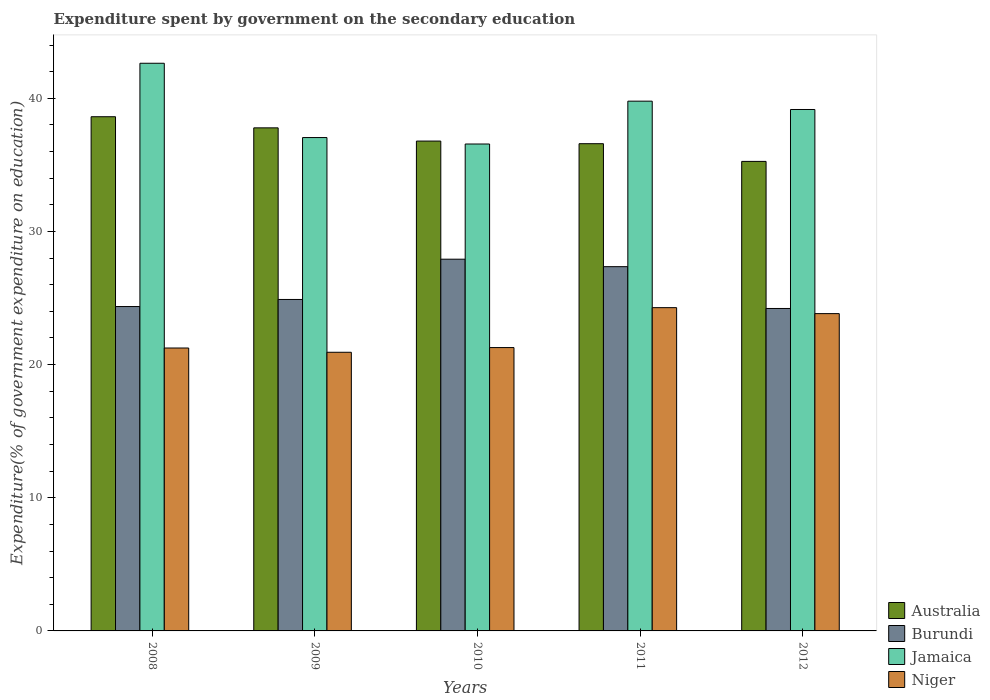How many groups of bars are there?
Offer a terse response. 5. What is the label of the 1st group of bars from the left?
Provide a succinct answer. 2008. What is the expenditure spent by government on the secondary education in Burundi in 2009?
Keep it short and to the point. 24.89. Across all years, what is the maximum expenditure spent by government on the secondary education in Burundi?
Give a very brief answer. 27.92. Across all years, what is the minimum expenditure spent by government on the secondary education in Niger?
Your answer should be compact. 20.93. In which year was the expenditure spent by government on the secondary education in Niger minimum?
Your response must be concise. 2009. What is the total expenditure spent by government on the secondary education in Niger in the graph?
Keep it short and to the point. 111.56. What is the difference between the expenditure spent by government on the secondary education in Australia in 2010 and that in 2011?
Your answer should be very brief. 0.2. What is the difference between the expenditure spent by government on the secondary education in Niger in 2011 and the expenditure spent by government on the secondary education in Jamaica in 2010?
Offer a terse response. -12.29. What is the average expenditure spent by government on the secondary education in Niger per year?
Your answer should be very brief. 22.31. In the year 2011, what is the difference between the expenditure spent by government on the secondary education in Niger and expenditure spent by government on the secondary education in Burundi?
Your answer should be very brief. -3.08. What is the ratio of the expenditure spent by government on the secondary education in Australia in 2008 to that in 2009?
Offer a very short reply. 1.02. What is the difference between the highest and the second highest expenditure spent by government on the secondary education in Niger?
Give a very brief answer. 0.45. What is the difference between the highest and the lowest expenditure spent by government on the secondary education in Jamaica?
Keep it short and to the point. 6.06. Is it the case that in every year, the sum of the expenditure spent by government on the secondary education in Niger and expenditure spent by government on the secondary education in Burundi is greater than the sum of expenditure spent by government on the secondary education in Jamaica and expenditure spent by government on the secondary education in Australia?
Keep it short and to the point. No. What does the 4th bar from the left in 2011 represents?
Your response must be concise. Niger. What does the 2nd bar from the right in 2011 represents?
Provide a succinct answer. Jamaica. How many bars are there?
Offer a terse response. 20. Are all the bars in the graph horizontal?
Offer a very short reply. No. Does the graph contain any zero values?
Give a very brief answer. No. How many legend labels are there?
Provide a succinct answer. 4. What is the title of the graph?
Offer a terse response. Expenditure spent by government on the secondary education. What is the label or title of the X-axis?
Your answer should be compact. Years. What is the label or title of the Y-axis?
Your answer should be compact. Expenditure(% of government expenditure on education). What is the Expenditure(% of government expenditure on education) in Australia in 2008?
Your answer should be compact. 38.62. What is the Expenditure(% of government expenditure on education) of Burundi in 2008?
Your answer should be very brief. 24.36. What is the Expenditure(% of government expenditure on education) of Jamaica in 2008?
Your answer should be compact. 42.63. What is the Expenditure(% of government expenditure on education) in Niger in 2008?
Offer a very short reply. 21.25. What is the Expenditure(% of government expenditure on education) in Australia in 2009?
Keep it short and to the point. 37.78. What is the Expenditure(% of government expenditure on education) of Burundi in 2009?
Offer a very short reply. 24.89. What is the Expenditure(% of government expenditure on education) of Jamaica in 2009?
Keep it short and to the point. 37.05. What is the Expenditure(% of government expenditure on education) in Niger in 2009?
Your answer should be compact. 20.93. What is the Expenditure(% of government expenditure on education) of Australia in 2010?
Offer a terse response. 36.79. What is the Expenditure(% of government expenditure on education) of Burundi in 2010?
Give a very brief answer. 27.92. What is the Expenditure(% of government expenditure on education) in Jamaica in 2010?
Offer a very short reply. 36.57. What is the Expenditure(% of government expenditure on education) in Niger in 2010?
Ensure brevity in your answer.  21.28. What is the Expenditure(% of government expenditure on education) of Australia in 2011?
Provide a short and direct response. 36.59. What is the Expenditure(% of government expenditure on education) in Burundi in 2011?
Provide a short and direct response. 27.36. What is the Expenditure(% of government expenditure on education) of Jamaica in 2011?
Provide a succinct answer. 39.79. What is the Expenditure(% of government expenditure on education) of Niger in 2011?
Provide a short and direct response. 24.28. What is the Expenditure(% of government expenditure on education) of Australia in 2012?
Your answer should be very brief. 35.26. What is the Expenditure(% of government expenditure on education) in Burundi in 2012?
Your answer should be very brief. 24.22. What is the Expenditure(% of government expenditure on education) of Jamaica in 2012?
Offer a terse response. 39.16. What is the Expenditure(% of government expenditure on education) of Niger in 2012?
Give a very brief answer. 23.83. Across all years, what is the maximum Expenditure(% of government expenditure on education) in Australia?
Offer a very short reply. 38.62. Across all years, what is the maximum Expenditure(% of government expenditure on education) of Burundi?
Your answer should be compact. 27.92. Across all years, what is the maximum Expenditure(% of government expenditure on education) in Jamaica?
Make the answer very short. 42.63. Across all years, what is the maximum Expenditure(% of government expenditure on education) in Niger?
Keep it short and to the point. 24.28. Across all years, what is the minimum Expenditure(% of government expenditure on education) in Australia?
Give a very brief answer. 35.26. Across all years, what is the minimum Expenditure(% of government expenditure on education) in Burundi?
Offer a very short reply. 24.22. Across all years, what is the minimum Expenditure(% of government expenditure on education) of Jamaica?
Your answer should be compact. 36.57. Across all years, what is the minimum Expenditure(% of government expenditure on education) of Niger?
Offer a terse response. 20.93. What is the total Expenditure(% of government expenditure on education) in Australia in the graph?
Provide a short and direct response. 185.04. What is the total Expenditure(% of government expenditure on education) of Burundi in the graph?
Ensure brevity in your answer.  128.74. What is the total Expenditure(% of government expenditure on education) of Jamaica in the graph?
Provide a short and direct response. 195.2. What is the total Expenditure(% of government expenditure on education) of Niger in the graph?
Provide a succinct answer. 111.56. What is the difference between the Expenditure(% of government expenditure on education) in Australia in 2008 and that in 2009?
Your response must be concise. 0.83. What is the difference between the Expenditure(% of government expenditure on education) in Burundi in 2008 and that in 2009?
Your answer should be very brief. -0.53. What is the difference between the Expenditure(% of government expenditure on education) in Jamaica in 2008 and that in 2009?
Your answer should be very brief. 5.58. What is the difference between the Expenditure(% of government expenditure on education) in Niger in 2008 and that in 2009?
Your answer should be very brief. 0.32. What is the difference between the Expenditure(% of government expenditure on education) of Australia in 2008 and that in 2010?
Your answer should be compact. 1.83. What is the difference between the Expenditure(% of government expenditure on education) in Burundi in 2008 and that in 2010?
Offer a terse response. -3.56. What is the difference between the Expenditure(% of government expenditure on education) of Jamaica in 2008 and that in 2010?
Your answer should be compact. 6.06. What is the difference between the Expenditure(% of government expenditure on education) in Niger in 2008 and that in 2010?
Ensure brevity in your answer.  -0.03. What is the difference between the Expenditure(% of government expenditure on education) of Australia in 2008 and that in 2011?
Your answer should be very brief. 2.03. What is the difference between the Expenditure(% of government expenditure on education) of Burundi in 2008 and that in 2011?
Offer a very short reply. -2.99. What is the difference between the Expenditure(% of government expenditure on education) in Jamaica in 2008 and that in 2011?
Ensure brevity in your answer.  2.85. What is the difference between the Expenditure(% of government expenditure on education) in Niger in 2008 and that in 2011?
Offer a very short reply. -3.03. What is the difference between the Expenditure(% of government expenditure on education) of Australia in 2008 and that in 2012?
Your response must be concise. 3.35. What is the difference between the Expenditure(% of government expenditure on education) of Burundi in 2008 and that in 2012?
Your answer should be compact. 0.15. What is the difference between the Expenditure(% of government expenditure on education) in Jamaica in 2008 and that in 2012?
Offer a terse response. 3.47. What is the difference between the Expenditure(% of government expenditure on education) of Niger in 2008 and that in 2012?
Give a very brief answer. -2.58. What is the difference between the Expenditure(% of government expenditure on education) in Burundi in 2009 and that in 2010?
Keep it short and to the point. -3.02. What is the difference between the Expenditure(% of government expenditure on education) of Jamaica in 2009 and that in 2010?
Your answer should be very brief. 0.48. What is the difference between the Expenditure(% of government expenditure on education) of Niger in 2009 and that in 2010?
Your answer should be very brief. -0.35. What is the difference between the Expenditure(% of government expenditure on education) of Australia in 2009 and that in 2011?
Your response must be concise. 1.19. What is the difference between the Expenditure(% of government expenditure on education) of Burundi in 2009 and that in 2011?
Provide a short and direct response. -2.46. What is the difference between the Expenditure(% of government expenditure on education) in Jamaica in 2009 and that in 2011?
Give a very brief answer. -2.73. What is the difference between the Expenditure(% of government expenditure on education) of Niger in 2009 and that in 2011?
Your answer should be compact. -3.35. What is the difference between the Expenditure(% of government expenditure on education) in Australia in 2009 and that in 2012?
Offer a terse response. 2.52. What is the difference between the Expenditure(% of government expenditure on education) in Burundi in 2009 and that in 2012?
Make the answer very short. 0.68. What is the difference between the Expenditure(% of government expenditure on education) in Jamaica in 2009 and that in 2012?
Offer a terse response. -2.11. What is the difference between the Expenditure(% of government expenditure on education) in Niger in 2009 and that in 2012?
Offer a terse response. -2.9. What is the difference between the Expenditure(% of government expenditure on education) in Australia in 2010 and that in 2011?
Offer a very short reply. 0.2. What is the difference between the Expenditure(% of government expenditure on education) in Burundi in 2010 and that in 2011?
Your response must be concise. 0.56. What is the difference between the Expenditure(% of government expenditure on education) in Jamaica in 2010 and that in 2011?
Make the answer very short. -3.22. What is the difference between the Expenditure(% of government expenditure on education) of Niger in 2010 and that in 2011?
Your answer should be very brief. -3. What is the difference between the Expenditure(% of government expenditure on education) in Australia in 2010 and that in 2012?
Your answer should be very brief. 1.53. What is the difference between the Expenditure(% of government expenditure on education) of Burundi in 2010 and that in 2012?
Offer a very short reply. 3.7. What is the difference between the Expenditure(% of government expenditure on education) in Jamaica in 2010 and that in 2012?
Offer a very short reply. -2.59. What is the difference between the Expenditure(% of government expenditure on education) in Niger in 2010 and that in 2012?
Your answer should be very brief. -2.55. What is the difference between the Expenditure(% of government expenditure on education) in Australia in 2011 and that in 2012?
Make the answer very short. 1.33. What is the difference between the Expenditure(% of government expenditure on education) of Burundi in 2011 and that in 2012?
Give a very brief answer. 3.14. What is the difference between the Expenditure(% of government expenditure on education) of Jamaica in 2011 and that in 2012?
Your answer should be very brief. 0.63. What is the difference between the Expenditure(% of government expenditure on education) of Niger in 2011 and that in 2012?
Ensure brevity in your answer.  0.45. What is the difference between the Expenditure(% of government expenditure on education) of Australia in 2008 and the Expenditure(% of government expenditure on education) of Burundi in 2009?
Offer a very short reply. 13.72. What is the difference between the Expenditure(% of government expenditure on education) of Australia in 2008 and the Expenditure(% of government expenditure on education) of Jamaica in 2009?
Offer a very short reply. 1.56. What is the difference between the Expenditure(% of government expenditure on education) of Australia in 2008 and the Expenditure(% of government expenditure on education) of Niger in 2009?
Your response must be concise. 17.69. What is the difference between the Expenditure(% of government expenditure on education) in Burundi in 2008 and the Expenditure(% of government expenditure on education) in Jamaica in 2009?
Make the answer very short. -12.69. What is the difference between the Expenditure(% of government expenditure on education) of Burundi in 2008 and the Expenditure(% of government expenditure on education) of Niger in 2009?
Provide a succinct answer. 3.44. What is the difference between the Expenditure(% of government expenditure on education) in Jamaica in 2008 and the Expenditure(% of government expenditure on education) in Niger in 2009?
Provide a succinct answer. 21.71. What is the difference between the Expenditure(% of government expenditure on education) of Australia in 2008 and the Expenditure(% of government expenditure on education) of Burundi in 2010?
Offer a very short reply. 10.7. What is the difference between the Expenditure(% of government expenditure on education) of Australia in 2008 and the Expenditure(% of government expenditure on education) of Jamaica in 2010?
Give a very brief answer. 2.05. What is the difference between the Expenditure(% of government expenditure on education) in Australia in 2008 and the Expenditure(% of government expenditure on education) in Niger in 2010?
Keep it short and to the point. 17.34. What is the difference between the Expenditure(% of government expenditure on education) of Burundi in 2008 and the Expenditure(% of government expenditure on education) of Jamaica in 2010?
Your answer should be very brief. -12.21. What is the difference between the Expenditure(% of government expenditure on education) in Burundi in 2008 and the Expenditure(% of government expenditure on education) in Niger in 2010?
Offer a very short reply. 3.08. What is the difference between the Expenditure(% of government expenditure on education) of Jamaica in 2008 and the Expenditure(% of government expenditure on education) of Niger in 2010?
Offer a terse response. 21.35. What is the difference between the Expenditure(% of government expenditure on education) of Australia in 2008 and the Expenditure(% of government expenditure on education) of Burundi in 2011?
Keep it short and to the point. 11.26. What is the difference between the Expenditure(% of government expenditure on education) in Australia in 2008 and the Expenditure(% of government expenditure on education) in Jamaica in 2011?
Offer a terse response. -1.17. What is the difference between the Expenditure(% of government expenditure on education) of Australia in 2008 and the Expenditure(% of government expenditure on education) of Niger in 2011?
Your response must be concise. 14.34. What is the difference between the Expenditure(% of government expenditure on education) in Burundi in 2008 and the Expenditure(% of government expenditure on education) in Jamaica in 2011?
Your response must be concise. -15.42. What is the difference between the Expenditure(% of government expenditure on education) in Burundi in 2008 and the Expenditure(% of government expenditure on education) in Niger in 2011?
Make the answer very short. 0.08. What is the difference between the Expenditure(% of government expenditure on education) in Jamaica in 2008 and the Expenditure(% of government expenditure on education) in Niger in 2011?
Make the answer very short. 18.35. What is the difference between the Expenditure(% of government expenditure on education) in Australia in 2008 and the Expenditure(% of government expenditure on education) in Burundi in 2012?
Give a very brief answer. 14.4. What is the difference between the Expenditure(% of government expenditure on education) of Australia in 2008 and the Expenditure(% of government expenditure on education) of Jamaica in 2012?
Make the answer very short. -0.54. What is the difference between the Expenditure(% of government expenditure on education) of Australia in 2008 and the Expenditure(% of government expenditure on education) of Niger in 2012?
Provide a short and direct response. 14.79. What is the difference between the Expenditure(% of government expenditure on education) of Burundi in 2008 and the Expenditure(% of government expenditure on education) of Jamaica in 2012?
Your response must be concise. -14.8. What is the difference between the Expenditure(% of government expenditure on education) of Burundi in 2008 and the Expenditure(% of government expenditure on education) of Niger in 2012?
Provide a short and direct response. 0.53. What is the difference between the Expenditure(% of government expenditure on education) of Jamaica in 2008 and the Expenditure(% of government expenditure on education) of Niger in 2012?
Offer a very short reply. 18.8. What is the difference between the Expenditure(% of government expenditure on education) of Australia in 2009 and the Expenditure(% of government expenditure on education) of Burundi in 2010?
Provide a short and direct response. 9.86. What is the difference between the Expenditure(% of government expenditure on education) in Australia in 2009 and the Expenditure(% of government expenditure on education) in Jamaica in 2010?
Your response must be concise. 1.21. What is the difference between the Expenditure(% of government expenditure on education) in Australia in 2009 and the Expenditure(% of government expenditure on education) in Niger in 2010?
Your response must be concise. 16.5. What is the difference between the Expenditure(% of government expenditure on education) of Burundi in 2009 and the Expenditure(% of government expenditure on education) of Jamaica in 2010?
Make the answer very short. -11.67. What is the difference between the Expenditure(% of government expenditure on education) in Burundi in 2009 and the Expenditure(% of government expenditure on education) in Niger in 2010?
Give a very brief answer. 3.61. What is the difference between the Expenditure(% of government expenditure on education) of Jamaica in 2009 and the Expenditure(% of government expenditure on education) of Niger in 2010?
Provide a short and direct response. 15.77. What is the difference between the Expenditure(% of government expenditure on education) of Australia in 2009 and the Expenditure(% of government expenditure on education) of Burundi in 2011?
Offer a very short reply. 10.43. What is the difference between the Expenditure(% of government expenditure on education) in Australia in 2009 and the Expenditure(% of government expenditure on education) in Jamaica in 2011?
Make the answer very short. -2. What is the difference between the Expenditure(% of government expenditure on education) of Australia in 2009 and the Expenditure(% of government expenditure on education) of Niger in 2011?
Give a very brief answer. 13.5. What is the difference between the Expenditure(% of government expenditure on education) in Burundi in 2009 and the Expenditure(% of government expenditure on education) in Jamaica in 2011?
Make the answer very short. -14.89. What is the difference between the Expenditure(% of government expenditure on education) of Burundi in 2009 and the Expenditure(% of government expenditure on education) of Niger in 2011?
Your answer should be compact. 0.61. What is the difference between the Expenditure(% of government expenditure on education) of Jamaica in 2009 and the Expenditure(% of government expenditure on education) of Niger in 2011?
Offer a terse response. 12.77. What is the difference between the Expenditure(% of government expenditure on education) of Australia in 2009 and the Expenditure(% of government expenditure on education) of Burundi in 2012?
Give a very brief answer. 13.57. What is the difference between the Expenditure(% of government expenditure on education) in Australia in 2009 and the Expenditure(% of government expenditure on education) in Jamaica in 2012?
Provide a succinct answer. -1.38. What is the difference between the Expenditure(% of government expenditure on education) of Australia in 2009 and the Expenditure(% of government expenditure on education) of Niger in 2012?
Ensure brevity in your answer.  13.95. What is the difference between the Expenditure(% of government expenditure on education) of Burundi in 2009 and the Expenditure(% of government expenditure on education) of Jamaica in 2012?
Provide a short and direct response. -14.27. What is the difference between the Expenditure(% of government expenditure on education) in Burundi in 2009 and the Expenditure(% of government expenditure on education) in Niger in 2012?
Make the answer very short. 1.06. What is the difference between the Expenditure(% of government expenditure on education) in Jamaica in 2009 and the Expenditure(% of government expenditure on education) in Niger in 2012?
Offer a terse response. 13.22. What is the difference between the Expenditure(% of government expenditure on education) in Australia in 2010 and the Expenditure(% of government expenditure on education) in Burundi in 2011?
Make the answer very short. 9.43. What is the difference between the Expenditure(% of government expenditure on education) in Australia in 2010 and the Expenditure(% of government expenditure on education) in Jamaica in 2011?
Give a very brief answer. -3. What is the difference between the Expenditure(% of government expenditure on education) in Australia in 2010 and the Expenditure(% of government expenditure on education) in Niger in 2011?
Offer a very short reply. 12.51. What is the difference between the Expenditure(% of government expenditure on education) of Burundi in 2010 and the Expenditure(% of government expenditure on education) of Jamaica in 2011?
Make the answer very short. -11.87. What is the difference between the Expenditure(% of government expenditure on education) of Burundi in 2010 and the Expenditure(% of government expenditure on education) of Niger in 2011?
Give a very brief answer. 3.64. What is the difference between the Expenditure(% of government expenditure on education) in Jamaica in 2010 and the Expenditure(% of government expenditure on education) in Niger in 2011?
Offer a terse response. 12.29. What is the difference between the Expenditure(% of government expenditure on education) of Australia in 2010 and the Expenditure(% of government expenditure on education) of Burundi in 2012?
Offer a very short reply. 12.57. What is the difference between the Expenditure(% of government expenditure on education) in Australia in 2010 and the Expenditure(% of government expenditure on education) in Jamaica in 2012?
Offer a terse response. -2.37. What is the difference between the Expenditure(% of government expenditure on education) in Australia in 2010 and the Expenditure(% of government expenditure on education) in Niger in 2012?
Your response must be concise. 12.96. What is the difference between the Expenditure(% of government expenditure on education) of Burundi in 2010 and the Expenditure(% of government expenditure on education) of Jamaica in 2012?
Your answer should be compact. -11.24. What is the difference between the Expenditure(% of government expenditure on education) of Burundi in 2010 and the Expenditure(% of government expenditure on education) of Niger in 2012?
Your answer should be compact. 4.09. What is the difference between the Expenditure(% of government expenditure on education) in Jamaica in 2010 and the Expenditure(% of government expenditure on education) in Niger in 2012?
Offer a terse response. 12.74. What is the difference between the Expenditure(% of government expenditure on education) in Australia in 2011 and the Expenditure(% of government expenditure on education) in Burundi in 2012?
Provide a succinct answer. 12.38. What is the difference between the Expenditure(% of government expenditure on education) in Australia in 2011 and the Expenditure(% of government expenditure on education) in Jamaica in 2012?
Your answer should be very brief. -2.57. What is the difference between the Expenditure(% of government expenditure on education) of Australia in 2011 and the Expenditure(% of government expenditure on education) of Niger in 2012?
Keep it short and to the point. 12.76. What is the difference between the Expenditure(% of government expenditure on education) of Burundi in 2011 and the Expenditure(% of government expenditure on education) of Jamaica in 2012?
Provide a short and direct response. -11.8. What is the difference between the Expenditure(% of government expenditure on education) in Burundi in 2011 and the Expenditure(% of government expenditure on education) in Niger in 2012?
Provide a short and direct response. 3.53. What is the difference between the Expenditure(% of government expenditure on education) in Jamaica in 2011 and the Expenditure(% of government expenditure on education) in Niger in 2012?
Your response must be concise. 15.96. What is the average Expenditure(% of government expenditure on education) in Australia per year?
Provide a short and direct response. 37.01. What is the average Expenditure(% of government expenditure on education) in Burundi per year?
Provide a succinct answer. 25.75. What is the average Expenditure(% of government expenditure on education) of Jamaica per year?
Provide a short and direct response. 39.04. What is the average Expenditure(% of government expenditure on education) in Niger per year?
Offer a very short reply. 22.31. In the year 2008, what is the difference between the Expenditure(% of government expenditure on education) of Australia and Expenditure(% of government expenditure on education) of Burundi?
Provide a short and direct response. 14.25. In the year 2008, what is the difference between the Expenditure(% of government expenditure on education) of Australia and Expenditure(% of government expenditure on education) of Jamaica?
Make the answer very short. -4.02. In the year 2008, what is the difference between the Expenditure(% of government expenditure on education) of Australia and Expenditure(% of government expenditure on education) of Niger?
Offer a terse response. 17.37. In the year 2008, what is the difference between the Expenditure(% of government expenditure on education) in Burundi and Expenditure(% of government expenditure on education) in Jamaica?
Ensure brevity in your answer.  -18.27. In the year 2008, what is the difference between the Expenditure(% of government expenditure on education) in Burundi and Expenditure(% of government expenditure on education) in Niger?
Ensure brevity in your answer.  3.12. In the year 2008, what is the difference between the Expenditure(% of government expenditure on education) in Jamaica and Expenditure(% of government expenditure on education) in Niger?
Give a very brief answer. 21.39. In the year 2009, what is the difference between the Expenditure(% of government expenditure on education) in Australia and Expenditure(% of government expenditure on education) in Burundi?
Provide a short and direct response. 12.89. In the year 2009, what is the difference between the Expenditure(% of government expenditure on education) in Australia and Expenditure(% of government expenditure on education) in Jamaica?
Provide a succinct answer. 0.73. In the year 2009, what is the difference between the Expenditure(% of government expenditure on education) of Australia and Expenditure(% of government expenditure on education) of Niger?
Offer a terse response. 16.86. In the year 2009, what is the difference between the Expenditure(% of government expenditure on education) in Burundi and Expenditure(% of government expenditure on education) in Jamaica?
Provide a succinct answer. -12.16. In the year 2009, what is the difference between the Expenditure(% of government expenditure on education) of Burundi and Expenditure(% of government expenditure on education) of Niger?
Provide a succinct answer. 3.97. In the year 2009, what is the difference between the Expenditure(% of government expenditure on education) of Jamaica and Expenditure(% of government expenditure on education) of Niger?
Give a very brief answer. 16.13. In the year 2010, what is the difference between the Expenditure(% of government expenditure on education) in Australia and Expenditure(% of government expenditure on education) in Burundi?
Offer a terse response. 8.87. In the year 2010, what is the difference between the Expenditure(% of government expenditure on education) in Australia and Expenditure(% of government expenditure on education) in Jamaica?
Provide a succinct answer. 0.22. In the year 2010, what is the difference between the Expenditure(% of government expenditure on education) in Australia and Expenditure(% of government expenditure on education) in Niger?
Make the answer very short. 15.51. In the year 2010, what is the difference between the Expenditure(% of government expenditure on education) of Burundi and Expenditure(% of government expenditure on education) of Jamaica?
Your answer should be compact. -8.65. In the year 2010, what is the difference between the Expenditure(% of government expenditure on education) of Burundi and Expenditure(% of government expenditure on education) of Niger?
Your response must be concise. 6.64. In the year 2010, what is the difference between the Expenditure(% of government expenditure on education) of Jamaica and Expenditure(% of government expenditure on education) of Niger?
Your answer should be very brief. 15.29. In the year 2011, what is the difference between the Expenditure(% of government expenditure on education) of Australia and Expenditure(% of government expenditure on education) of Burundi?
Your response must be concise. 9.24. In the year 2011, what is the difference between the Expenditure(% of government expenditure on education) in Australia and Expenditure(% of government expenditure on education) in Jamaica?
Provide a short and direct response. -3.19. In the year 2011, what is the difference between the Expenditure(% of government expenditure on education) of Australia and Expenditure(% of government expenditure on education) of Niger?
Keep it short and to the point. 12.31. In the year 2011, what is the difference between the Expenditure(% of government expenditure on education) in Burundi and Expenditure(% of government expenditure on education) in Jamaica?
Your answer should be compact. -12.43. In the year 2011, what is the difference between the Expenditure(% of government expenditure on education) in Burundi and Expenditure(% of government expenditure on education) in Niger?
Your answer should be very brief. 3.08. In the year 2011, what is the difference between the Expenditure(% of government expenditure on education) of Jamaica and Expenditure(% of government expenditure on education) of Niger?
Offer a very short reply. 15.51. In the year 2012, what is the difference between the Expenditure(% of government expenditure on education) in Australia and Expenditure(% of government expenditure on education) in Burundi?
Offer a terse response. 11.05. In the year 2012, what is the difference between the Expenditure(% of government expenditure on education) of Australia and Expenditure(% of government expenditure on education) of Jamaica?
Give a very brief answer. -3.9. In the year 2012, what is the difference between the Expenditure(% of government expenditure on education) of Australia and Expenditure(% of government expenditure on education) of Niger?
Offer a very short reply. 11.43. In the year 2012, what is the difference between the Expenditure(% of government expenditure on education) in Burundi and Expenditure(% of government expenditure on education) in Jamaica?
Your answer should be compact. -14.94. In the year 2012, what is the difference between the Expenditure(% of government expenditure on education) in Burundi and Expenditure(% of government expenditure on education) in Niger?
Make the answer very short. 0.39. In the year 2012, what is the difference between the Expenditure(% of government expenditure on education) of Jamaica and Expenditure(% of government expenditure on education) of Niger?
Offer a terse response. 15.33. What is the ratio of the Expenditure(% of government expenditure on education) of Australia in 2008 to that in 2009?
Ensure brevity in your answer.  1.02. What is the ratio of the Expenditure(% of government expenditure on education) of Burundi in 2008 to that in 2009?
Make the answer very short. 0.98. What is the ratio of the Expenditure(% of government expenditure on education) of Jamaica in 2008 to that in 2009?
Your response must be concise. 1.15. What is the ratio of the Expenditure(% of government expenditure on education) in Niger in 2008 to that in 2009?
Offer a terse response. 1.02. What is the ratio of the Expenditure(% of government expenditure on education) in Australia in 2008 to that in 2010?
Ensure brevity in your answer.  1.05. What is the ratio of the Expenditure(% of government expenditure on education) in Burundi in 2008 to that in 2010?
Offer a terse response. 0.87. What is the ratio of the Expenditure(% of government expenditure on education) of Jamaica in 2008 to that in 2010?
Your response must be concise. 1.17. What is the ratio of the Expenditure(% of government expenditure on education) of Australia in 2008 to that in 2011?
Offer a very short reply. 1.06. What is the ratio of the Expenditure(% of government expenditure on education) of Burundi in 2008 to that in 2011?
Provide a succinct answer. 0.89. What is the ratio of the Expenditure(% of government expenditure on education) of Jamaica in 2008 to that in 2011?
Keep it short and to the point. 1.07. What is the ratio of the Expenditure(% of government expenditure on education) of Niger in 2008 to that in 2011?
Provide a short and direct response. 0.88. What is the ratio of the Expenditure(% of government expenditure on education) of Australia in 2008 to that in 2012?
Give a very brief answer. 1.1. What is the ratio of the Expenditure(% of government expenditure on education) of Burundi in 2008 to that in 2012?
Give a very brief answer. 1.01. What is the ratio of the Expenditure(% of government expenditure on education) of Jamaica in 2008 to that in 2012?
Your answer should be very brief. 1.09. What is the ratio of the Expenditure(% of government expenditure on education) in Niger in 2008 to that in 2012?
Give a very brief answer. 0.89. What is the ratio of the Expenditure(% of government expenditure on education) in Australia in 2009 to that in 2010?
Keep it short and to the point. 1.03. What is the ratio of the Expenditure(% of government expenditure on education) in Burundi in 2009 to that in 2010?
Provide a succinct answer. 0.89. What is the ratio of the Expenditure(% of government expenditure on education) of Jamaica in 2009 to that in 2010?
Offer a terse response. 1.01. What is the ratio of the Expenditure(% of government expenditure on education) of Niger in 2009 to that in 2010?
Provide a succinct answer. 0.98. What is the ratio of the Expenditure(% of government expenditure on education) of Australia in 2009 to that in 2011?
Ensure brevity in your answer.  1.03. What is the ratio of the Expenditure(% of government expenditure on education) in Burundi in 2009 to that in 2011?
Give a very brief answer. 0.91. What is the ratio of the Expenditure(% of government expenditure on education) in Jamaica in 2009 to that in 2011?
Provide a short and direct response. 0.93. What is the ratio of the Expenditure(% of government expenditure on education) of Niger in 2009 to that in 2011?
Your answer should be compact. 0.86. What is the ratio of the Expenditure(% of government expenditure on education) in Australia in 2009 to that in 2012?
Your response must be concise. 1.07. What is the ratio of the Expenditure(% of government expenditure on education) in Burundi in 2009 to that in 2012?
Provide a short and direct response. 1.03. What is the ratio of the Expenditure(% of government expenditure on education) in Jamaica in 2009 to that in 2012?
Provide a short and direct response. 0.95. What is the ratio of the Expenditure(% of government expenditure on education) of Niger in 2009 to that in 2012?
Ensure brevity in your answer.  0.88. What is the ratio of the Expenditure(% of government expenditure on education) of Australia in 2010 to that in 2011?
Provide a succinct answer. 1.01. What is the ratio of the Expenditure(% of government expenditure on education) in Burundi in 2010 to that in 2011?
Your response must be concise. 1.02. What is the ratio of the Expenditure(% of government expenditure on education) of Jamaica in 2010 to that in 2011?
Ensure brevity in your answer.  0.92. What is the ratio of the Expenditure(% of government expenditure on education) of Niger in 2010 to that in 2011?
Offer a terse response. 0.88. What is the ratio of the Expenditure(% of government expenditure on education) of Australia in 2010 to that in 2012?
Provide a succinct answer. 1.04. What is the ratio of the Expenditure(% of government expenditure on education) in Burundi in 2010 to that in 2012?
Give a very brief answer. 1.15. What is the ratio of the Expenditure(% of government expenditure on education) of Jamaica in 2010 to that in 2012?
Give a very brief answer. 0.93. What is the ratio of the Expenditure(% of government expenditure on education) in Niger in 2010 to that in 2012?
Offer a very short reply. 0.89. What is the ratio of the Expenditure(% of government expenditure on education) in Australia in 2011 to that in 2012?
Offer a very short reply. 1.04. What is the ratio of the Expenditure(% of government expenditure on education) in Burundi in 2011 to that in 2012?
Your response must be concise. 1.13. What is the ratio of the Expenditure(% of government expenditure on education) of Niger in 2011 to that in 2012?
Keep it short and to the point. 1.02. What is the difference between the highest and the second highest Expenditure(% of government expenditure on education) of Australia?
Your answer should be very brief. 0.83. What is the difference between the highest and the second highest Expenditure(% of government expenditure on education) of Burundi?
Give a very brief answer. 0.56. What is the difference between the highest and the second highest Expenditure(% of government expenditure on education) in Jamaica?
Make the answer very short. 2.85. What is the difference between the highest and the second highest Expenditure(% of government expenditure on education) of Niger?
Provide a short and direct response. 0.45. What is the difference between the highest and the lowest Expenditure(% of government expenditure on education) of Australia?
Offer a very short reply. 3.35. What is the difference between the highest and the lowest Expenditure(% of government expenditure on education) of Burundi?
Your response must be concise. 3.7. What is the difference between the highest and the lowest Expenditure(% of government expenditure on education) of Jamaica?
Your answer should be very brief. 6.06. What is the difference between the highest and the lowest Expenditure(% of government expenditure on education) of Niger?
Keep it short and to the point. 3.35. 